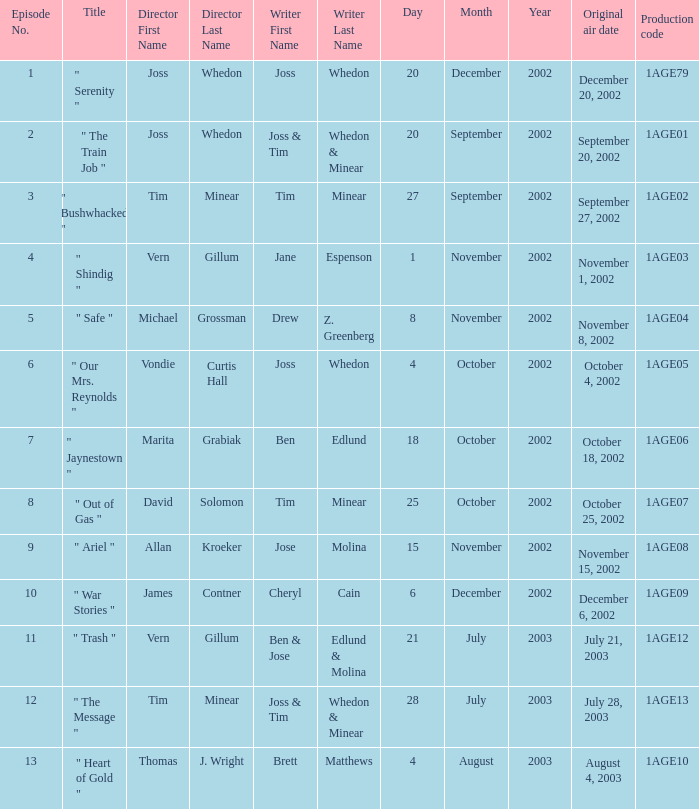What is the production code for the episode written by Drew Z. Greenberg? 1AGE04. 